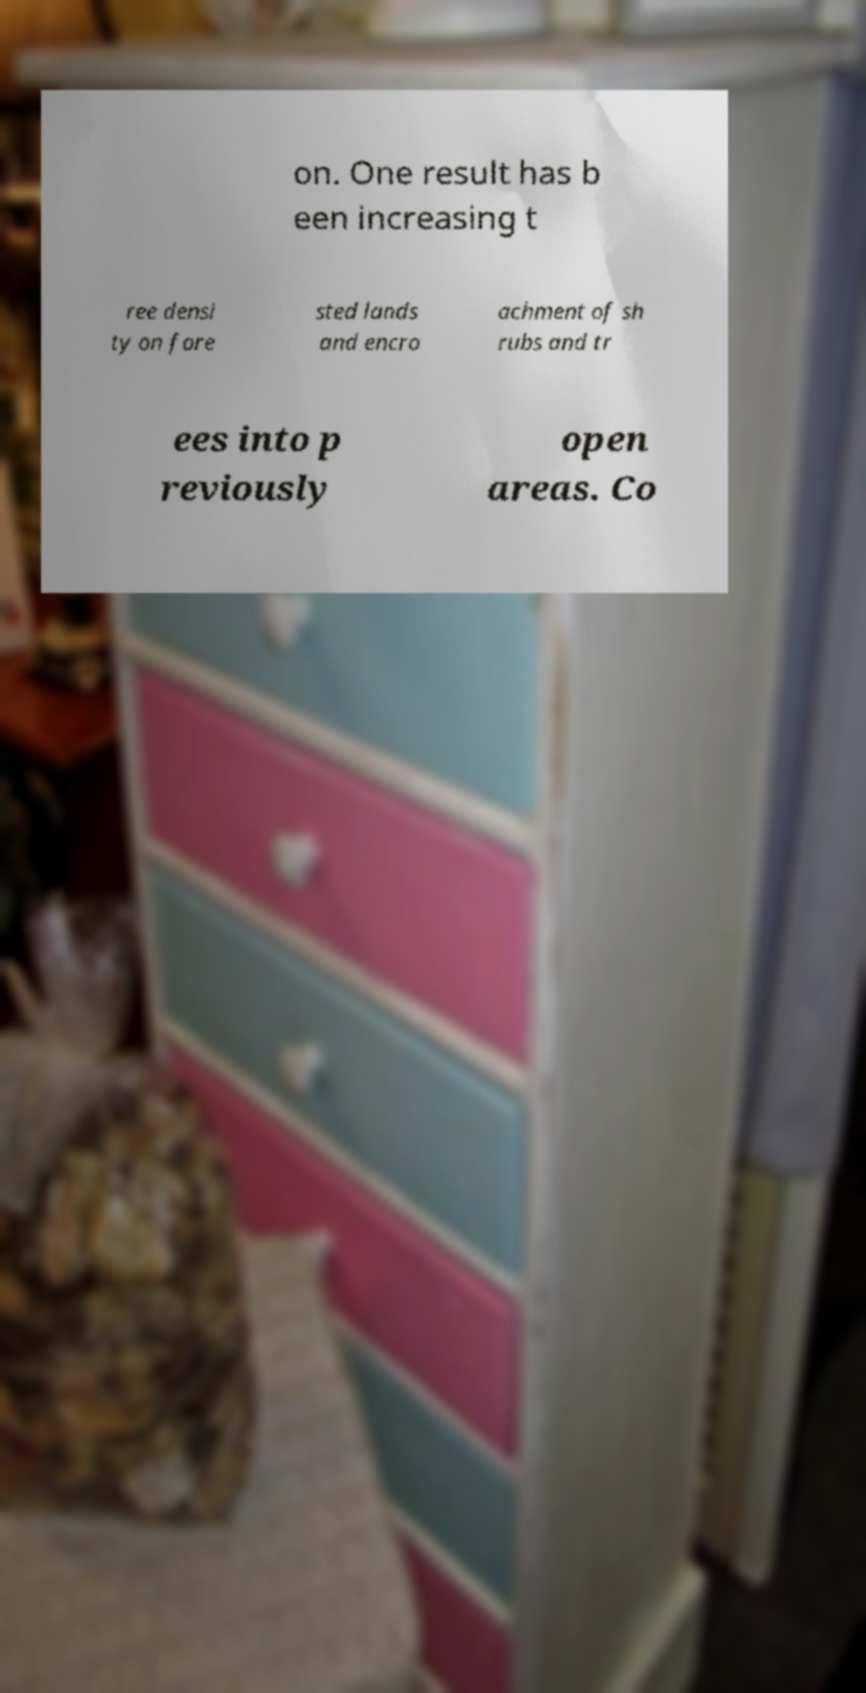I need the written content from this picture converted into text. Can you do that? on. One result has b een increasing t ree densi ty on fore sted lands and encro achment of sh rubs and tr ees into p reviously open areas. Co 